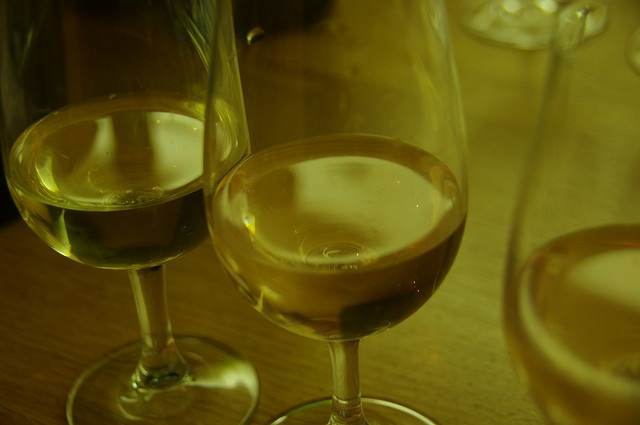Describe the objects in this image and their specific colors. I can see wine glass in black and olive tones, dining table in black and olive tones, wine glass in black and olive tones, wine glass in black, olive, and maroon tones, and wine glass in black and olive tones in this image. 